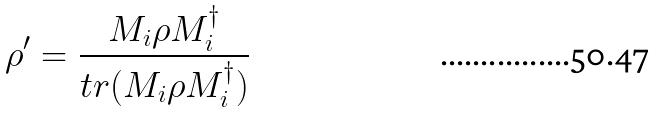<formula> <loc_0><loc_0><loc_500><loc_500>\rho ^ { \prime } = \frac { M _ { i } \rho M _ { i } ^ { \dagger } } { t r ( M _ { i } \rho M _ { i } ^ { \dagger } ) }</formula> 